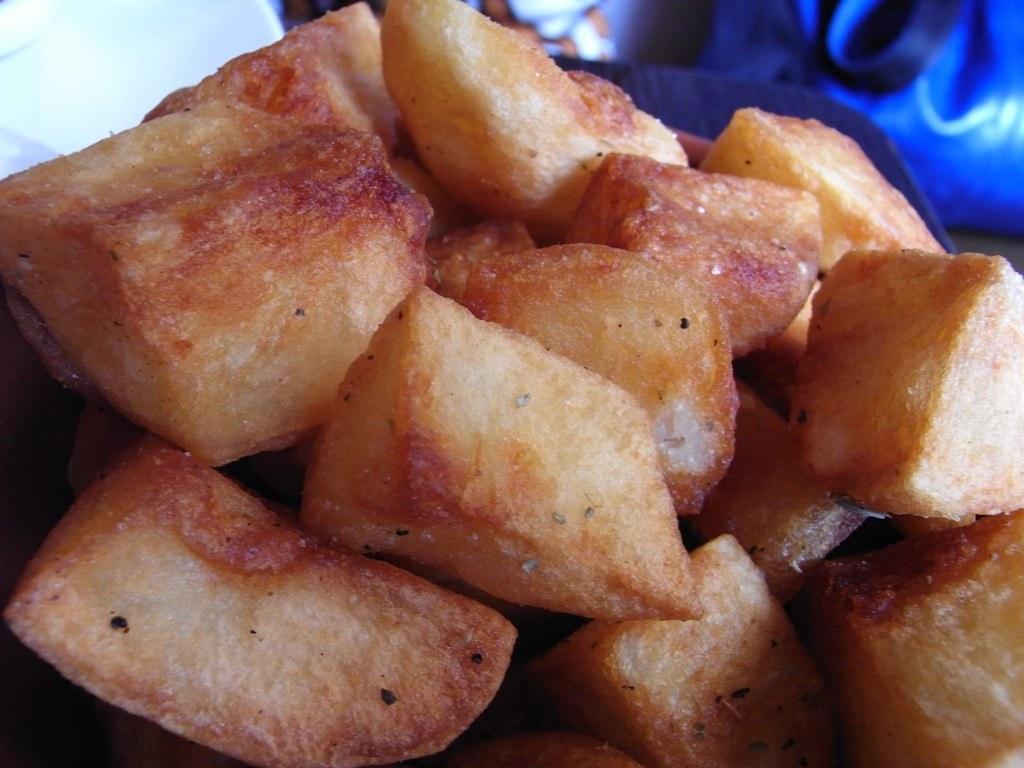Describe this image in one or two sentences. In the center of this picture we can see the food items. In the background we can see some other objects. 